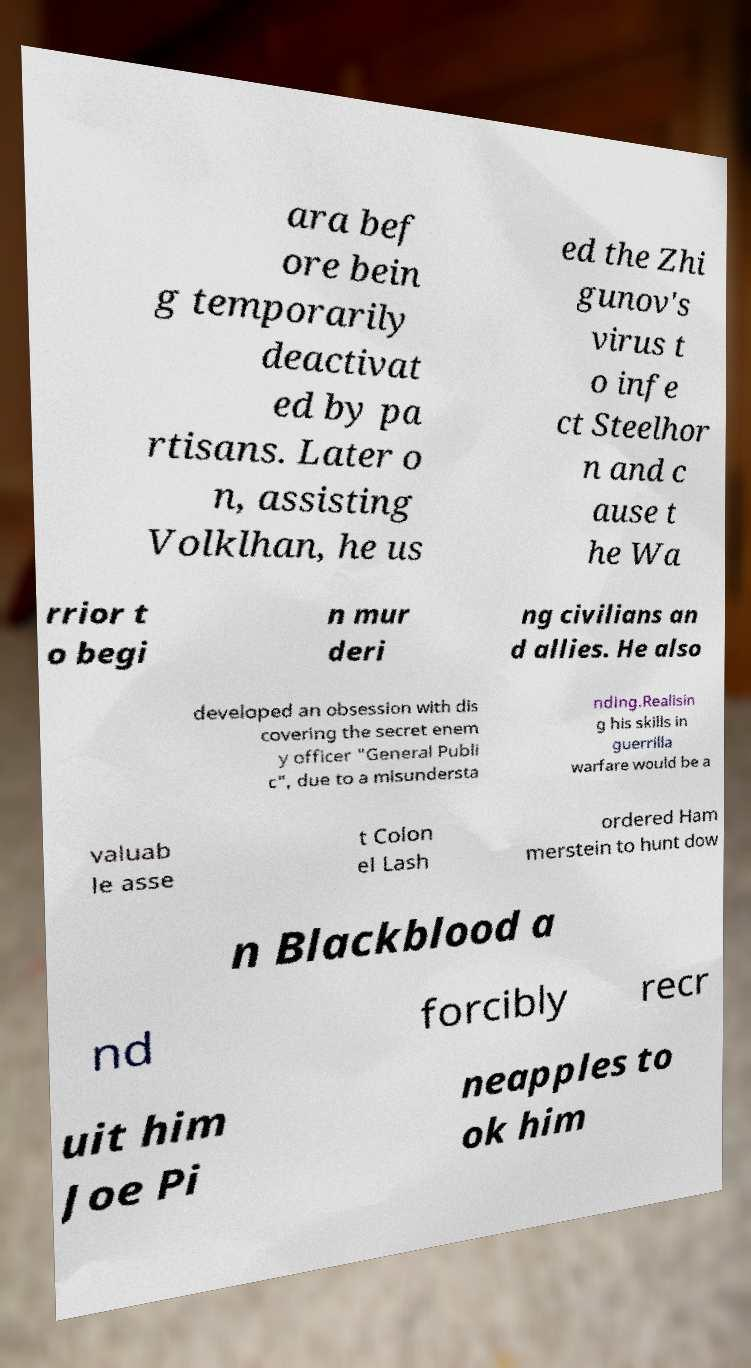For documentation purposes, I need the text within this image transcribed. Could you provide that? ara bef ore bein g temporarily deactivat ed by pa rtisans. Later o n, assisting Volklhan, he us ed the Zhi gunov's virus t o infe ct Steelhor n and c ause t he Wa rrior t o begi n mur deri ng civilians an d allies. He also developed an obsession with dis covering the secret enem y officer "General Publi c", due to a misundersta nding.Realisin g his skills in guerrilla warfare would be a valuab le asse t Colon el Lash ordered Ham merstein to hunt dow n Blackblood a nd forcibly recr uit him Joe Pi neapples to ok him 